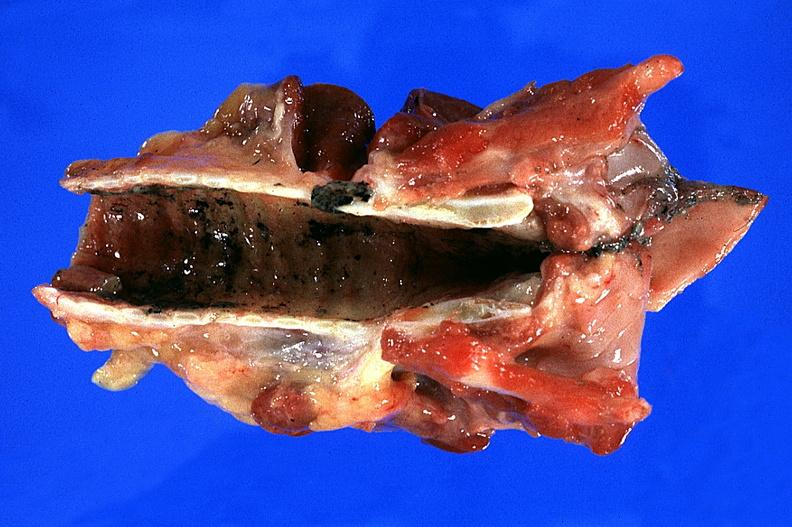what is present?
Answer the question using a single word or phrase. Respiratory 